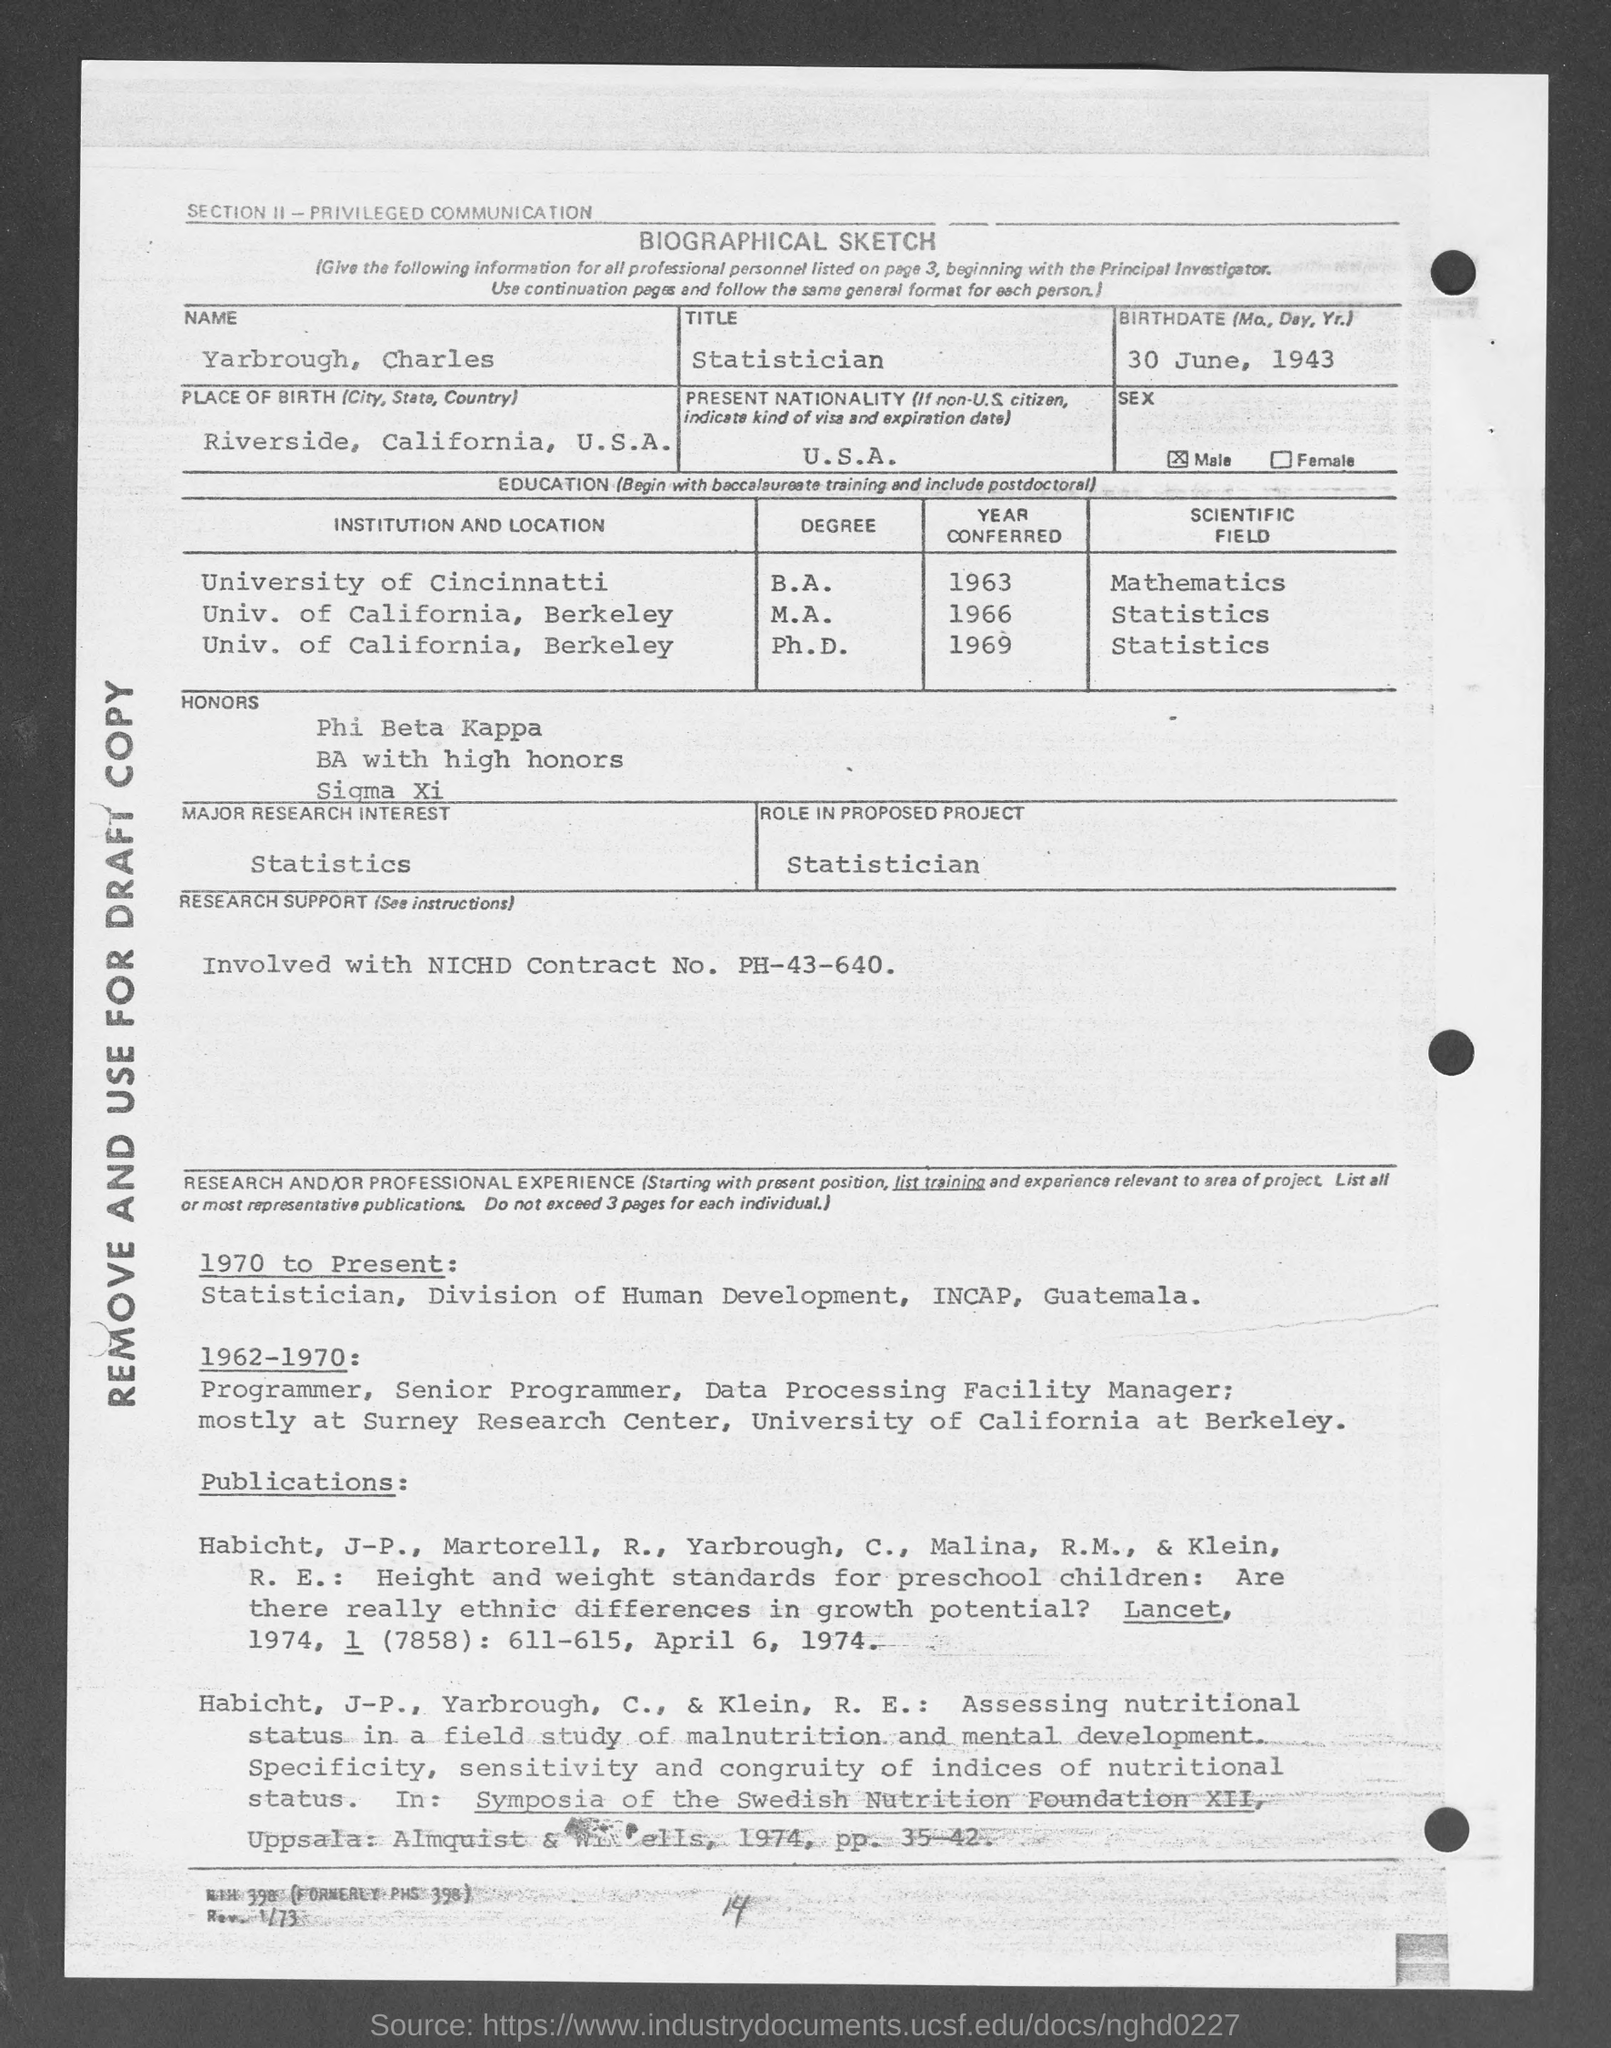What is the Title of the document?
Provide a short and direct response. Biographical Sketch. What is the Name?
Offer a very short reply. Yarbrough, Charles. What is the Title?
Provide a short and direct response. Statistician. What is the Birthdate?
Offer a very short reply. 30 June, 1943. What is the Place of Birth?
Your answer should be very brief. Riverside, california, u.s.a. What is the Present Nationality?
Your answer should be very brief. U.S.A. What is the Major Research Interest?
Offer a terse response. Statistics. What is the Role in proposed project?
Give a very brief answer. Statistician. When was he in University of Cincinnati?
Your answer should be very brief. 1963. 